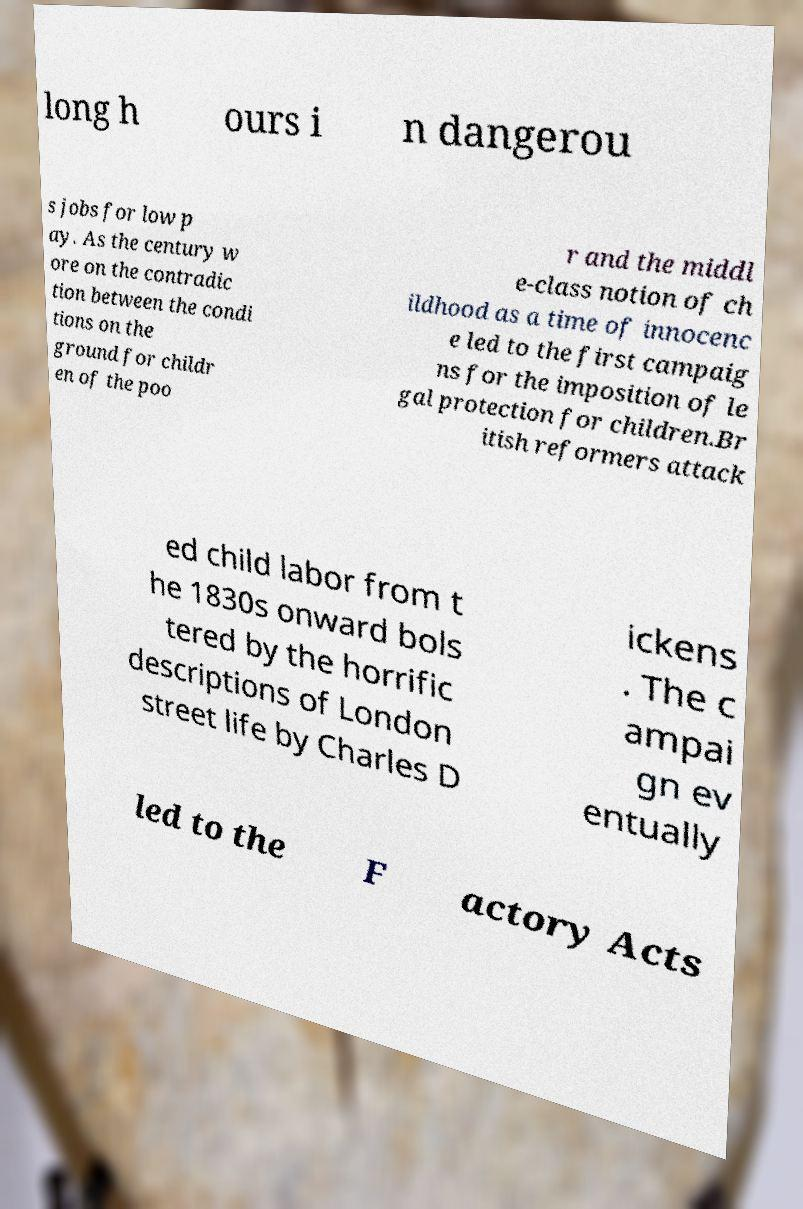For documentation purposes, I need the text within this image transcribed. Could you provide that? long h ours i n dangerou s jobs for low p ay. As the century w ore on the contradic tion between the condi tions on the ground for childr en of the poo r and the middl e-class notion of ch ildhood as a time of innocenc e led to the first campaig ns for the imposition of le gal protection for children.Br itish reformers attack ed child labor from t he 1830s onward bols tered by the horrific descriptions of London street life by Charles D ickens . The c ampai gn ev entually led to the F actory Acts 